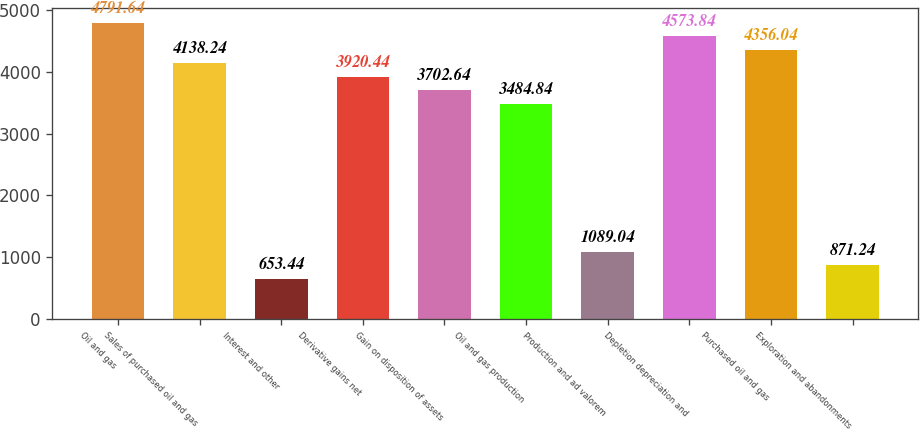Convert chart to OTSL. <chart><loc_0><loc_0><loc_500><loc_500><bar_chart><fcel>Oil and gas<fcel>Sales of purchased oil and gas<fcel>Interest and other<fcel>Derivative gains net<fcel>Gain on disposition of assets<fcel>Oil and gas production<fcel>Production and ad valorem<fcel>Depletion depreciation and<fcel>Purchased oil and gas<fcel>Exploration and abandonments<nl><fcel>4791.64<fcel>4138.24<fcel>653.44<fcel>3920.44<fcel>3702.64<fcel>3484.84<fcel>1089.04<fcel>4573.84<fcel>4356.04<fcel>871.24<nl></chart> 